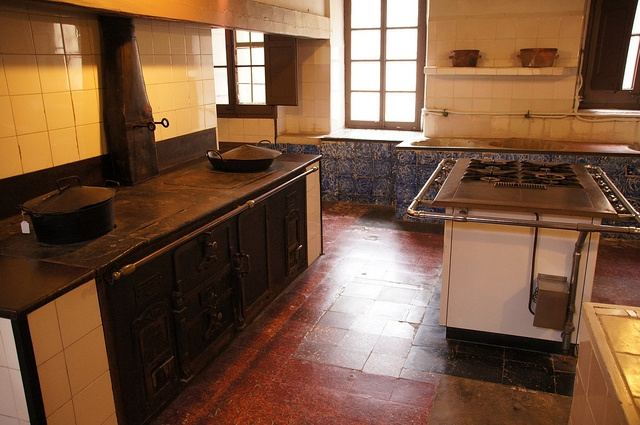Describe the objects in this image and their specific colors. I can see oven in black, tan, gray, and maroon tones, oven in black, maroon, and brown tones, sink in black, maroon, brown, and tan tones, bowl in black, maroon, and brown tones, and bowl in black, maroon, and brown tones in this image. 